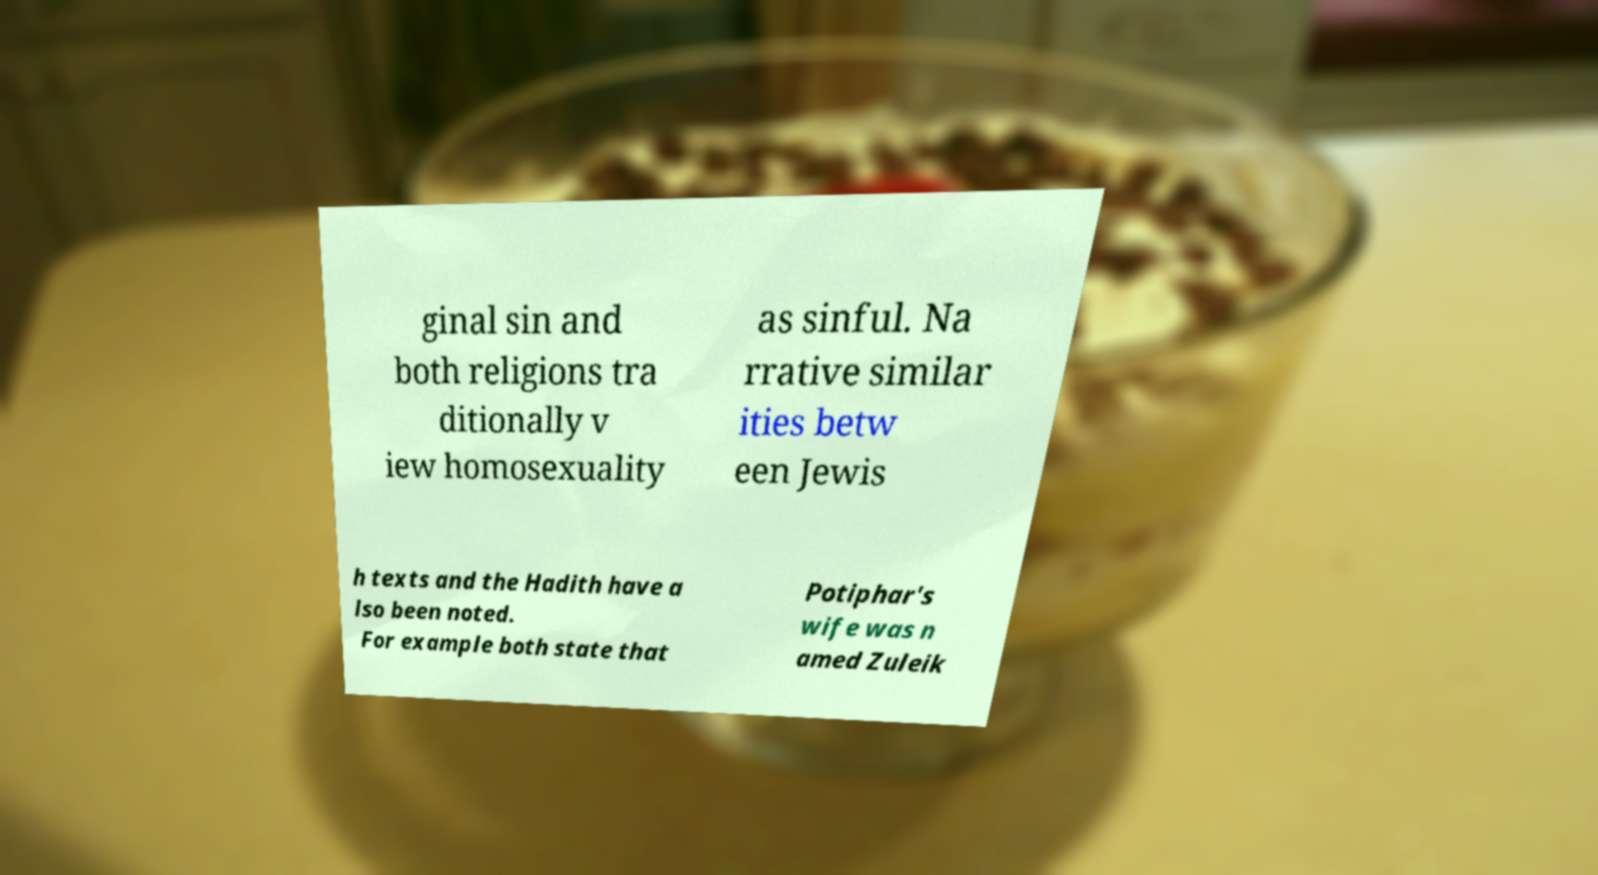I need the written content from this picture converted into text. Can you do that? ginal sin and both religions tra ditionally v iew homosexuality as sinful. Na rrative similar ities betw een Jewis h texts and the Hadith have a lso been noted. For example both state that Potiphar's wife was n amed Zuleik 